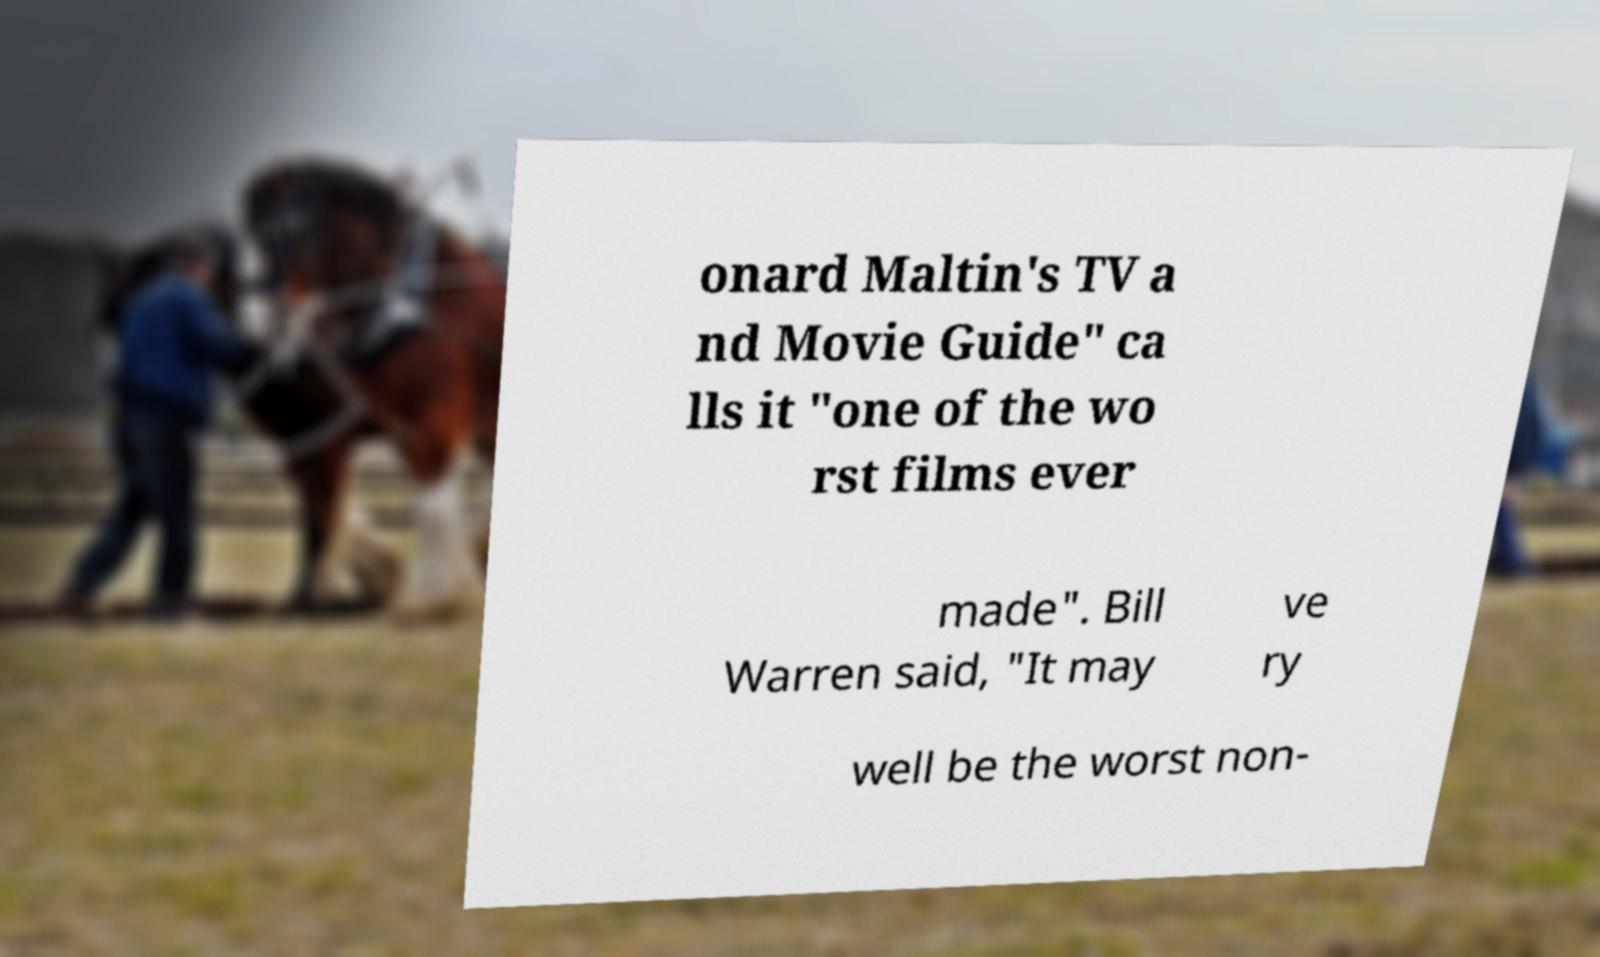Can you accurately transcribe the text from the provided image for me? onard Maltin's TV a nd Movie Guide" ca lls it "one of the wo rst films ever made". Bill Warren said, "It may ve ry well be the worst non- 